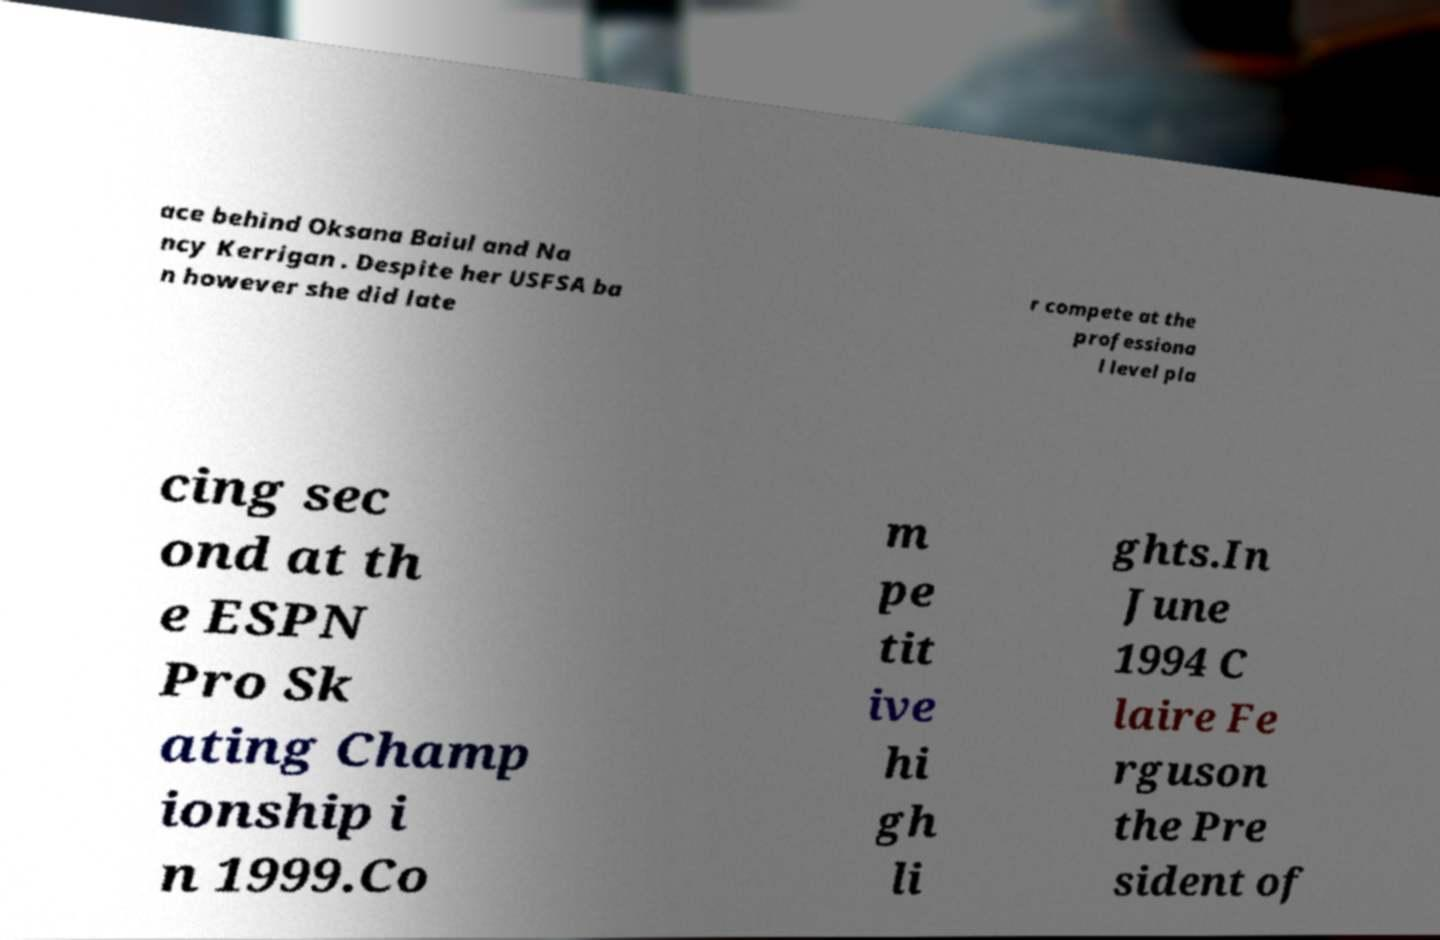What messages or text are displayed in this image? I need them in a readable, typed format. ace behind Oksana Baiul and Na ncy Kerrigan . Despite her USFSA ba n however she did late r compete at the professiona l level pla cing sec ond at th e ESPN Pro Sk ating Champ ionship i n 1999.Co m pe tit ive hi gh li ghts.In June 1994 C laire Fe rguson the Pre sident of 